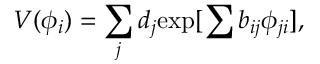Convert formula to latex. <formula><loc_0><loc_0><loc_500><loc_500>V ( \phi _ { i } ) = \sum _ { j } d _ { j } { \exp [ \sum b _ { i j } \phi _ { j i } ] } ,</formula> 